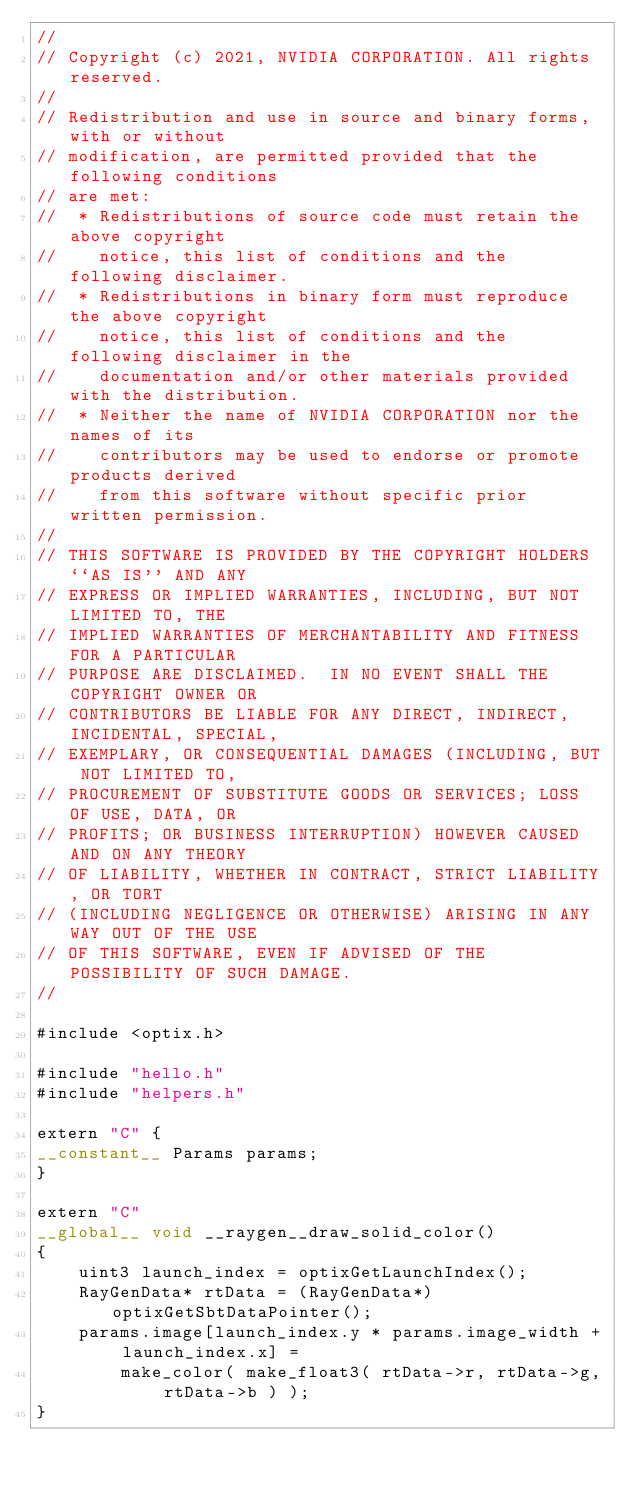Convert code to text. <code><loc_0><loc_0><loc_500><loc_500><_Cuda_>//
// Copyright (c) 2021, NVIDIA CORPORATION. All rights reserved.
//
// Redistribution and use in source and binary forms, with or without
// modification, are permitted provided that the following conditions
// are met:
//  * Redistributions of source code must retain the above copyright
//    notice, this list of conditions and the following disclaimer.
//  * Redistributions in binary form must reproduce the above copyright
//    notice, this list of conditions and the following disclaimer in the
//    documentation and/or other materials provided with the distribution.
//  * Neither the name of NVIDIA CORPORATION nor the names of its
//    contributors may be used to endorse or promote products derived
//    from this software without specific prior written permission.
//
// THIS SOFTWARE IS PROVIDED BY THE COPYRIGHT HOLDERS ``AS IS'' AND ANY
// EXPRESS OR IMPLIED WARRANTIES, INCLUDING, BUT NOT LIMITED TO, THE
// IMPLIED WARRANTIES OF MERCHANTABILITY AND FITNESS FOR A PARTICULAR
// PURPOSE ARE DISCLAIMED.  IN NO EVENT SHALL THE COPYRIGHT OWNER OR
// CONTRIBUTORS BE LIABLE FOR ANY DIRECT, INDIRECT, INCIDENTAL, SPECIAL,
// EXEMPLARY, OR CONSEQUENTIAL DAMAGES (INCLUDING, BUT NOT LIMITED TO,
// PROCUREMENT OF SUBSTITUTE GOODS OR SERVICES; LOSS OF USE, DATA, OR
// PROFITS; OR BUSINESS INTERRUPTION) HOWEVER CAUSED AND ON ANY THEORY
// OF LIABILITY, WHETHER IN CONTRACT, STRICT LIABILITY, OR TORT
// (INCLUDING NEGLIGENCE OR OTHERWISE) ARISING IN ANY WAY OUT OF THE USE
// OF THIS SOFTWARE, EVEN IF ADVISED OF THE POSSIBILITY OF SUCH DAMAGE.
//

#include <optix.h>

#include "hello.h"
#include "helpers.h"

extern "C" {
__constant__ Params params;
}

extern "C"
__global__ void __raygen__draw_solid_color()
{
    uint3 launch_index = optixGetLaunchIndex();
    RayGenData* rtData = (RayGenData*)optixGetSbtDataPointer();
    params.image[launch_index.y * params.image_width + launch_index.x] =
        make_color( make_float3( rtData->r, rtData->g, rtData->b ) );
}
</code> 